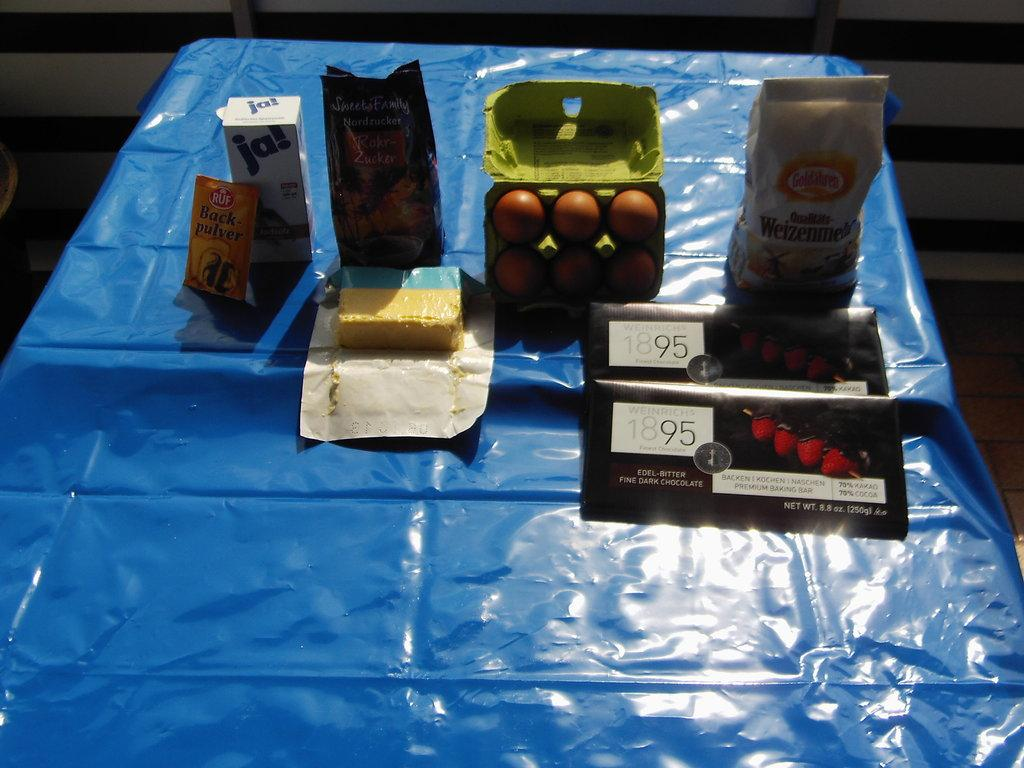What type of food items are present in the image? There are eggs and food packets in the image. Where are the eggs and food packets located? They are placed on a table. What can be seen covering the table in the image? There is a blue color cover on the table. What type of gun can be seen in the image? There is no gun present in the image. Is there a minister in the image? There is no minister present in the image. 